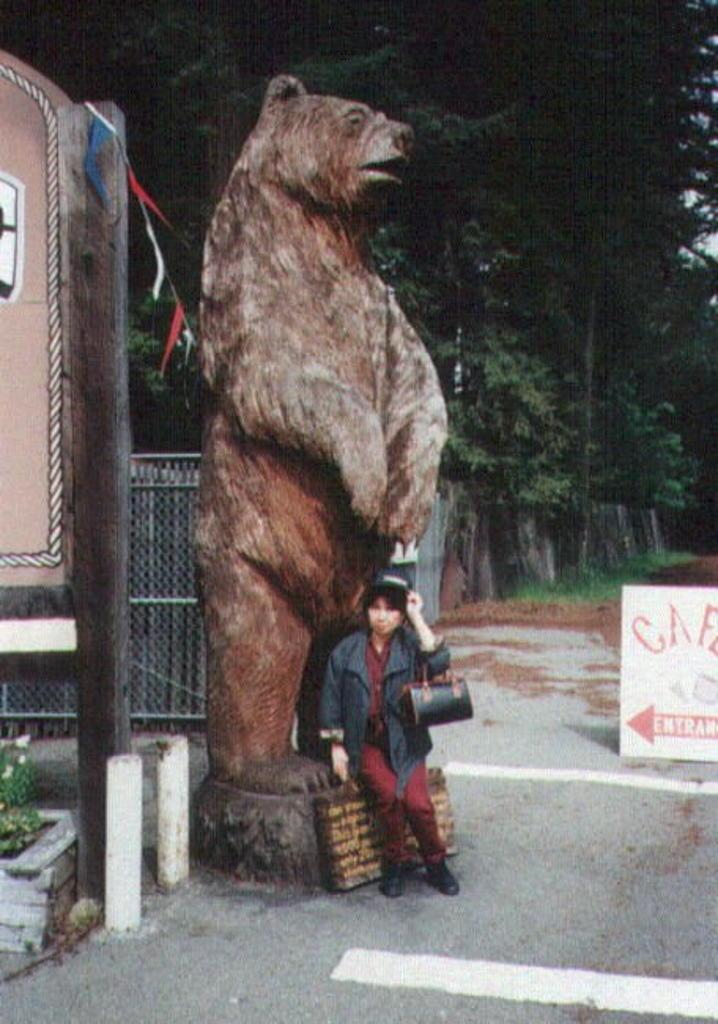Who is present in the image? There is a woman in the image. What is the woman wearing? The woman is wearing a blue jacket. What is the woman doing in the image? The woman is sitting. What can be seen hanging in the image? There are banners in the image. What type of barrier is visible in the image? There is a fence in the image. What type of statue can be seen in the image? There is a teddy bear statue in the image. What type of natural elements are present in the image? There are trees in the image. What type of light source is illuminating the paper in the image? There is no paper present in the image, so it cannot be illuminated by a light source. 